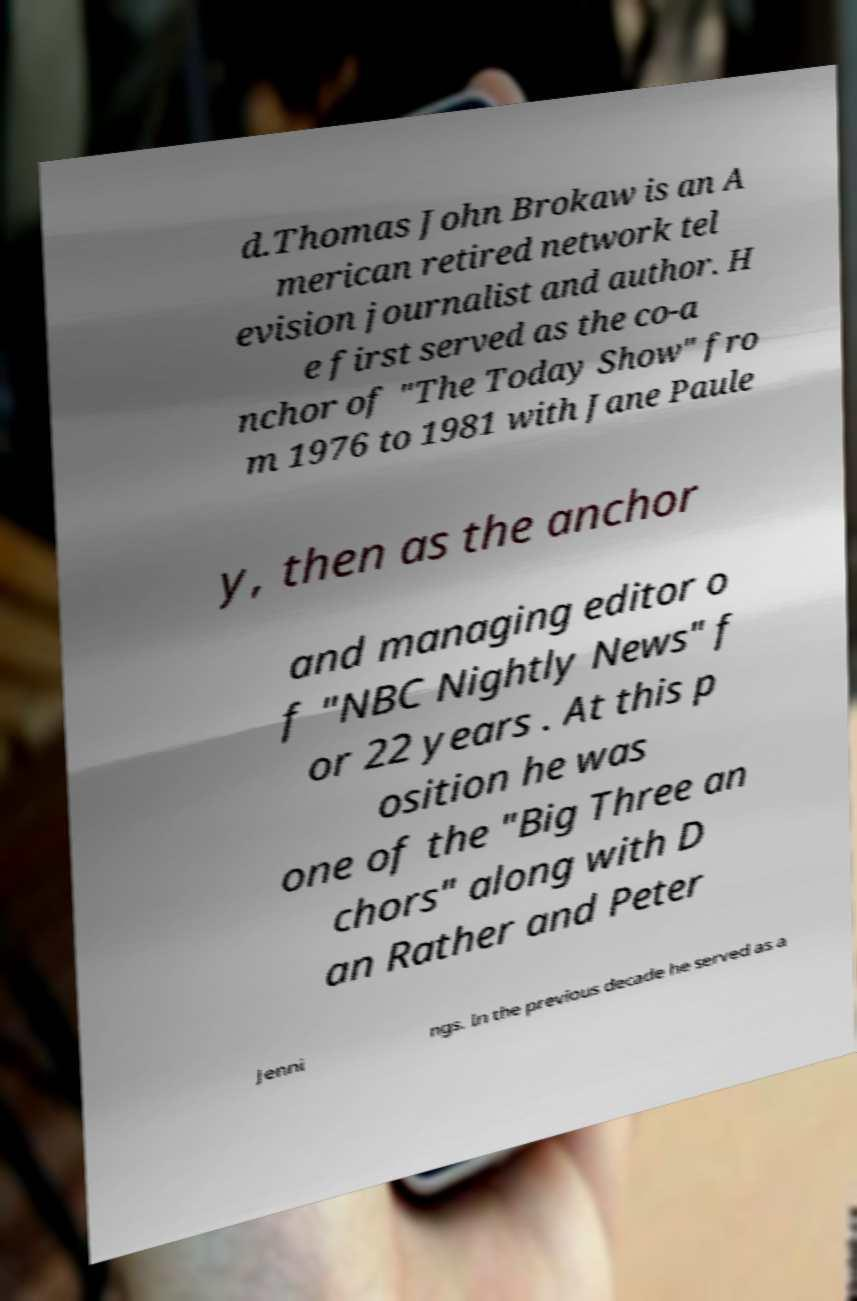Could you extract and type out the text from this image? d.Thomas John Brokaw is an A merican retired network tel evision journalist and author. H e first served as the co-a nchor of "The Today Show" fro m 1976 to 1981 with Jane Paule y, then as the anchor and managing editor o f "NBC Nightly News" f or 22 years . At this p osition he was one of the "Big Three an chors" along with D an Rather and Peter Jenni ngs. In the previous decade he served as a 